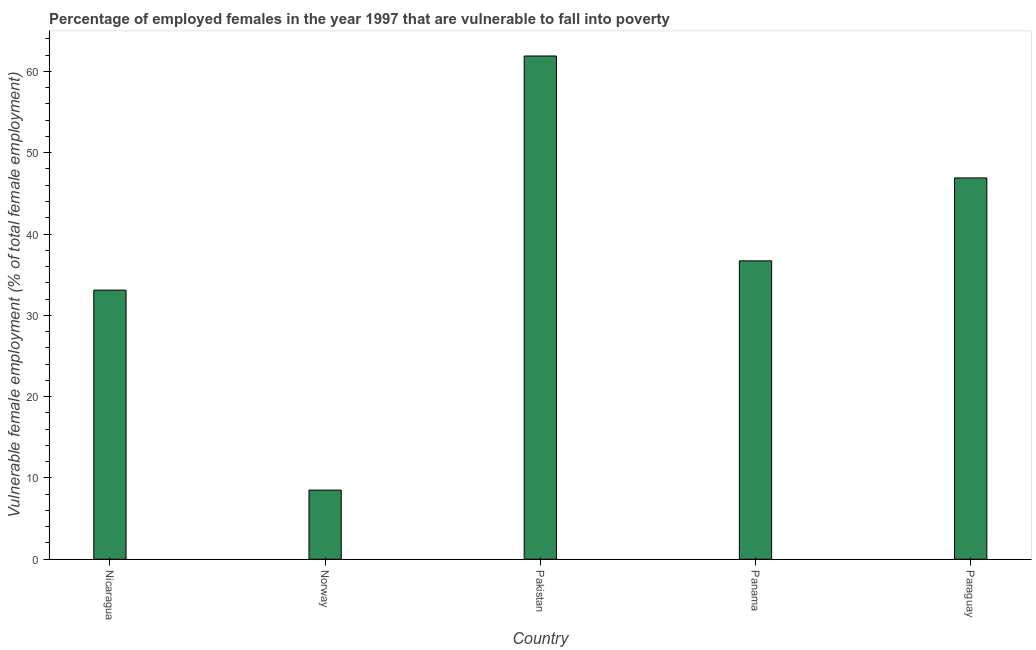What is the title of the graph?
Your answer should be very brief. Percentage of employed females in the year 1997 that are vulnerable to fall into poverty. What is the label or title of the X-axis?
Provide a succinct answer. Country. What is the label or title of the Y-axis?
Provide a succinct answer. Vulnerable female employment (% of total female employment). What is the percentage of employed females who are vulnerable to fall into poverty in Pakistan?
Make the answer very short. 61.9. Across all countries, what is the maximum percentage of employed females who are vulnerable to fall into poverty?
Provide a short and direct response. 61.9. Across all countries, what is the minimum percentage of employed females who are vulnerable to fall into poverty?
Ensure brevity in your answer.  8.5. In which country was the percentage of employed females who are vulnerable to fall into poverty maximum?
Provide a succinct answer. Pakistan. In which country was the percentage of employed females who are vulnerable to fall into poverty minimum?
Provide a short and direct response. Norway. What is the sum of the percentage of employed females who are vulnerable to fall into poverty?
Provide a succinct answer. 187.1. What is the average percentage of employed females who are vulnerable to fall into poverty per country?
Provide a succinct answer. 37.42. What is the median percentage of employed females who are vulnerable to fall into poverty?
Ensure brevity in your answer.  36.7. In how many countries, is the percentage of employed females who are vulnerable to fall into poverty greater than 60 %?
Provide a short and direct response. 1. What is the ratio of the percentage of employed females who are vulnerable to fall into poverty in Norway to that in Pakistan?
Your response must be concise. 0.14. Is the difference between the percentage of employed females who are vulnerable to fall into poverty in Nicaragua and Paraguay greater than the difference between any two countries?
Keep it short and to the point. No. Is the sum of the percentage of employed females who are vulnerable to fall into poverty in Norway and Paraguay greater than the maximum percentage of employed females who are vulnerable to fall into poverty across all countries?
Your response must be concise. No. What is the difference between the highest and the lowest percentage of employed females who are vulnerable to fall into poverty?
Keep it short and to the point. 53.4. How many countries are there in the graph?
Offer a terse response. 5. Are the values on the major ticks of Y-axis written in scientific E-notation?
Offer a terse response. No. What is the Vulnerable female employment (% of total female employment) of Nicaragua?
Make the answer very short. 33.1. What is the Vulnerable female employment (% of total female employment) of Norway?
Offer a very short reply. 8.5. What is the Vulnerable female employment (% of total female employment) in Pakistan?
Your answer should be very brief. 61.9. What is the Vulnerable female employment (% of total female employment) in Panama?
Offer a terse response. 36.7. What is the Vulnerable female employment (% of total female employment) of Paraguay?
Your answer should be very brief. 46.9. What is the difference between the Vulnerable female employment (% of total female employment) in Nicaragua and Norway?
Your answer should be very brief. 24.6. What is the difference between the Vulnerable female employment (% of total female employment) in Nicaragua and Pakistan?
Your answer should be compact. -28.8. What is the difference between the Vulnerable female employment (% of total female employment) in Nicaragua and Paraguay?
Provide a succinct answer. -13.8. What is the difference between the Vulnerable female employment (% of total female employment) in Norway and Pakistan?
Keep it short and to the point. -53.4. What is the difference between the Vulnerable female employment (% of total female employment) in Norway and Panama?
Your answer should be very brief. -28.2. What is the difference between the Vulnerable female employment (% of total female employment) in Norway and Paraguay?
Ensure brevity in your answer.  -38.4. What is the difference between the Vulnerable female employment (% of total female employment) in Pakistan and Panama?
Provide a succinct answer. 25.2. What is the difference between the Vulnerable female employment (% of total female employment) in Pakistan and Paraguay?
Your answer should be very brief. 15. What is the ratio of the Vulnerable female employment (% of total female employment) in Nicaragua to that in Norway?
Your answer should be very brief. 3.89. What is the ratio of the Vulnerable female employment (% of total female employment) in Nicaragua to that in Pakistan?
Provide a short and direct response. 0.54. What is the ratio of the Vulnerable female employment (% of total female employment) in Nicaragua to that in Panama?
Your answer should be very brief. 0.9. What is the ratio of the Vulnerable female employment (% of total female employment) in Nicaragua to that in Paraguay?
Your answer should be very brief. 0.71. What is the ratio of the Vulnerable female employment (% of total female employment) in Norway to that in Pakistan?
Keep it short and to the point. 0.14. What is the ratio of the Vulnerable female employment (% of total female employment) in Norway to that in Panama?
Ensure brevity in your answer.  0.23. What is the ratio of the Vulnerable female employment (% of total female employment) in Norway to that in Paraguay?
Provide a succinct answer. 0.18. What is the ratio of the Vulnerable female employment (% of total female employment) in Pakistan to that in Panama?
Offer a very short reply. 1.69. What is the ratio of the Vulnerable female employment (% of total female employment) in Pakistan to that in Paraguay?
Ensure brevity in your answer.  1.32. What is the ratio of the Vulnerable female employment (% of total female employment) in Panama to that in Paraguay?
Keep it short and to the point. 0.78. 